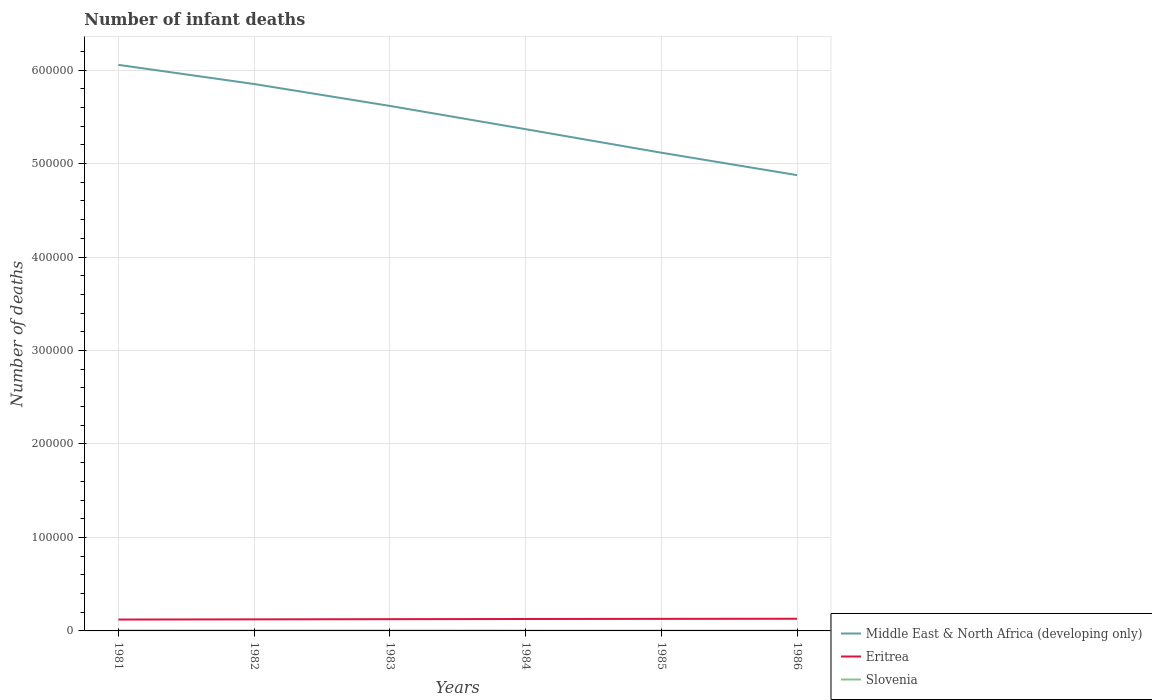How many different coloured lines are there?
Ensure brevity in your answer.  3. Across all years, what is the maximum number of infant deaths in Eritrea?
Provide a succinct answer. 1.22e+04. In which year was the number of infant deaths in Middle East & North Africa (developing only) maximum?
Your response must be concise. 1986. What is the total number of infant deaths in Eritrea in the graph?
Keep it short and to the point. -330. What is the difference between the highest and the second highest number of infant deaths in Eritrea?
Offer a terse response. 858. What is the difference between the highest and the lowest number of infant deaths in Slovenia?
Offer a very short reply. 3. Is the number of infant deaths in Middle East & North Africa (developing only) strictly greater than the number of infant deaths in Slovenia over the years?
Offer a terse response. No. How many years are there in the graph?
Provide a short and direct response. 6. What is the difference between two consecutive major ticks on the Y-axis?
Keep it short and to the point. 1.00e+05. Does the graph contain grids?
Provide a succinct answer. Yes. Where does the legend appear in the graph?
Your answer should be very brief. Bottom right. What is the title of the graph?
Keep it short and to the point. Number of infant deaths. What is the label or title of the Y-axis?
Keep it short and to the point. Number of deaths. What is the Number of deaths of Middle East & North Africa (developing only) in 1981?
Give a very brief answer. 6.06e+05. What is the Number of deaths in Eritrea in 1981?
Offer a very short reply. 1.22e+04. What is the Number of deaths in Slovenia in 1981?
Ensure brevity in your answer.  464. What is the Number of deaths in Middle East & North Africa (developing only) in 1982?
Provide a short and direct response. 5.85e+05. What is the Number of deaths of Eritrea in 1982?
Offer a terse response. 1.24e+04. What is the Number of deaths in Slovenia in 1982?
Make the answer very short. 424. What is the Number of deaths of Middle East & North Africa (developing only) in 1983?
Offer a very short reply. 5.62e+05. What is the Number of deaths in Eritrea in 1983?
Your answer should be compact. 1.26e+04. What is the Number of deaths of Slovenia in 1983?
Give a very brief answer. 387. What is the Number of deaths in Middle East & North Africa (developing only) in 1984?
Your answer should be very brief. 5.37e+05. What is the Number of deaths of Eritrea in 1984?
Provide a short and direct response. 1.28e+04. What is the Number of deaths of Slovenia in 1984?
Provide a short and direct response. 355. What is the Number of deaths of Middle East & North Africa (developing only) in 1985?
Keep it short and to the point. 5.12e+05. What is the Number of deaths in Eritrea in 1985?
Offer a terse response. 1.29e+04. What is the Number of deaths in Slovenia in 1985?
Offer a very short reply. 322. What is the Number of deaths of Middle East & North Africa (developing only) in 1986?
Give a very brief answer. 4.88e+05. What is the Number of deaths of Eritrea in 1986?
Your answer should be very brief. 1.30e+04. What is the Number of deaths of Slovenia in 1986?
Offer a very short reply. 295. Across all years, what is the maximum Number of deaths of Middle East & North Africa (developing only)?
Your answer should be compact. 6.06e+05. Across all years, what is the maximum Number of deaths of Eritrea?
Your response must be concise. 1.30e+04. Across all years, what is the maximum Number of deaths of Slovenia?
Your answer should be very brief. 464. Across all years, what is the minimum Number of deaths in Middle East & North Africa (developing only)?
Make the answer very short. 4.88e+05. Across all years, what is the minimum Number of deaths in Eritrea?
Provide a succinct answer. 1.22e+04. Across all years, what is the minimum Number of deaths of Slovenia?
Provide a succinct answer. 295. What is the total Number of deaths of Middle East & North Africa (developing only) in the graph?
Keep it short and to the point. 3.29e+06. What is the total Number of deaths of Eritrea in the graph?
Offer a very short reply. 7.58e+04. What is the total Number of deaths of Slovenia in the graph?
Your answer should be very brief. 2247. What is the difference between the Number of deaths of Middle East & North Africa (developing only) in 1981 and that in 1982?
Make the answer very short. 2.05e+04. What is the difference between the Number of deaths of Eritrea in 1981 and that in 1982?
Ensure brevity in your answer.  -206. What is the difference between the Number of deaths in Slovenia in 1981 and that in 1982?
Your answer should be compact. 40. What is the difference between the Number of deaths in Middle East & North Africa (developing only) in 1981 and that in 1983?
Offer a terse response. 4.39e+04. What is the difference between the Number of deaths in Eritrea in 1981 and that in 1983?
Give a very brief answer. -410. What is the difference between the Number of deaths of Slovenia in 1981 and that in 1983?
Your answer should be compact. 77. What is the difference between the Number of deaths of Middle East & North Africa (developing only) in 1981 and that in 1984?
Your answer should be very brief. 6.88e+04. What is the difference between the Number of deaths of Eritrea in 1981 and that in 1984?
Your answer should be compact. -592. What is the difference between the Number of deaths of Slovenia in 1981 and that in 1984?
Keep it short and to the point. 109. What is the difference between the Number of deaths of Middle East & North Africa (developing only) in 1981 and that in 1985?
Keep it short and to the point. 9.40e+04. What is the difference between the Number of deaths of Eritrea in 1981 and that in 1985?
Your answer should be very brief. -740. What is the difference between the Number of deaths in Slovenia in 1981 and that in 1985?
Your response must be concise. 142. What is the difference between the Number of deaths in Middle East & North Africa (developing only) in 1981 and that in 1986?
Make the answer very short. 1.18e+05. What is the difference between the Number of deaths in Eritrea in 1981 and that in 1986?
Offer a terse response. -858. What is the difference between the Number of deaths in Slovenia in 1981 and that in 1986?
Keep it short and to the point. 169. What is the difference between the Number of deaths in Middle East & North Africa (developing only) in 1982 and that in 1983?
Your response must be concise. 2.34e+04. What is the difference between the Number of deaths in Eritrea in 1982 and that in 1983?
Provide a succinct answer. -204. What is the difference between the Number of deaths of Middle East & North Africa (developing only) in 1982 and that in 1984?
Make the answer very short. 4.83e+04. What is the difference between the Number of deaths of Eritrea in 1982 and that in 1984?
Provide a succinct answer. -386. What is the difference between the Number of deaths of Slovenia in 1982 and that in 1984?
Give a very brief answer. 69. What is the difference between the Number of deaths of Middle East & North Africa (developing only) in 1982 and that in 1985?
Your response must be concise. 7.35e+04. What is the difference between the Number of deaths of Eritrea in 1982 and that in 1985?
Your answer should be compact. -534. What is the difference between the Number of deaths in Slovenia in 1982 and that in 1985?
Make the answer very short. 102. What is the difference between the Number of deaths in Middle East & North Africa (developing only) in 1982 and that in 1986?
Offer a terse response. 9.75e+04. What is the difference between the Number of deaths of Eritrea in 1982 and that in 1986?
Offer a terse response. -652. What is the difference between the Number of deaths of Slovenia in 1982 and that in 1986?
Your response must be concise. 129. What is the difference between the Number of deaths of Middle East & North Africa (developing only) in 1983 and that in 1984?
Offer a very short reply. 2.49e+04. What is the difference between the Number of deaths in Eritrea in 1983 and that in 1984?
Ensure brevity in your answer.  -182. What is the difference between the Number of deaths in Slovenia in 1983 and that in 1984?
Your response must be concise. 32. What is the difference between the Number of deaths in Middle East & North Africa (developing only) in 1983 and that in 1985?
Your response must be concise. 5.01e+04. What is the difference between the Number of deaths in Eritrea in 1983 and that in 1985?
Make the answer very short. -330. What is the difference between the Number of deaths in Middle East & North Africa (developing only) in 1983 and that in 1986?
Offer a very short reply. 7.41e+04. What is the difference between the Number of deaths of Eritrea in 1983 and that in 1986?
Provide a short and direct response. -448. What is the difference between the Number of deaths of Slovenia in 1983 and that in 1986?
Offer a terse response. 92. What is the difference between the Number of deaths in Middle East & North Africa (developing only) in 1984 and that in 1985?
Give a very brief answer. 2.52e+04. What is the difference between the Number of deaths of Eritrea in 1984 and that in 1985?
Your response must be concise. -148. What is the difference between the Number of deaths in Middle East & North Africa (developing only) in 1984 and that in 1986?
Your answer should be very brief. 4.92e+04. What is the difference between the Number of deaths of Eritrea in 1984 and that in 1986?
Offer a terse response. -266. What is the difference between the Number of deaths of Middle East & North Africa (developing only) in 1985 and that in 1986?
Provide a succinct answer. 2.40e+04. What is the difference between the Number of deaths of Eritrea in 1985 and that in 1986?
Your answer should be compact. -118. What is the difference between the Number of deaths in Slovenia in 1985 and that in 1986?
Give a very brief answer. 27. What is the difference between the Number of deaths of Middle East & North Africa (developing only) in 1981 and the Number of deaths of Eritrea in 1982?
Make the answer very short. 5.93e+05. What is the difference between the Number of deaths in Middle East & North Africa (developing only) in 1981 and the Number of deaths in Slovenia in 1982?
Give a very brief answer. 6.05e+05. What is the difference between the Number of deaths in Eritrea in 1981 and the Number of deaths in Slovenia in 1982?
Your response must be concise. 1.17e+04. What is the difference between the Number of deaths in Middle East & North Africa (developing only) in 1981 and the Number of deaths in Eritrea in 1983?
Give a very brief answer. 5.93e+05. What is the difference between the Number of deaths of Middle East & North Africa (developing only) in 1981 and the Number of deaths of Slovenia in 1983?
Give a very brief answer. 6.05e+05. What is the difference between the Number of deaths in Eritrea in 1981 and the Number of deaths in Slovenia in 1983?
Your response must be concise. 1.18e+04. What is the difference between the Number of deaths of Middle East & North Africa (developing only) in 1981 and the Number of deaths of Eritrea in 1984?
Provide a succinct answer. 5.93e+05. What is the difference between the Number of deaths in Middle East & North Africa (developing only) in 1981 and the Number of deaths in Slovenia in 1984?
Make the answer very short. 6.05e+05. What is the difference between the Number of deaths of Eritrea in 1981 and the Number of deaths of Slovenia in 1984?
Keep it short and to the point. 1.18e+04. What is the difference between the Number of deaths in Middle East & North Africa (developing only) in 1981 and the Number of deaths in Eritrea in 1985?
Make the answer very short. 5.93e+05. What is the difference between the Number of deaths of Middle East & North Africa (developing only) in 1981 and the Number of deaths of Slovenia in 1985?
Make the answer very short. 6.05e+05. What is the difference between the Number of deaths of Eritrea in 1981 and the Number of deaths of Slovenia in 1985?
Your answer should be compact. 1.18e+04. What is the difference between the Number of deaths in Middle East & North Africa (developing only) in 1981 and the Number of deaths in Eritrea in 1986?
Provide a short and direct response. 5.93e+05. What is the difference between the Number of deaths in Middle East & North Africa (developing only) in 1981 and the Number of deaths in Slovenia in 1986?
Your response must be concise. 6.05e+05. What is the difference between the Number of deaths of Eritrea in 1981 and the Number of deaths of Slovenia in 1986?
Offer a very short reply. 1.19e+04. What is the difference between the Number of deaths in Middle East & North Africa (developing only) in 1982 and the Number of deaths in Eritrea in 1983?
Provide a short and direct response. 5.73e+05. What is the difference between the Number of deaths of Middle East & North Africa (developing only) in 1982 and the Number of deaths of Slovenia in 1983?
Ensure brevity in your answer.  5.85e+05. What is the difference between the Number of deaths of Eritrea in 1982 and the Number of deaths of Slovenia in 1983?
Ensure brevity in your answer.  1.20e+04. What is the difference between the Number of deaths of Middle East & North Africa (developing only) in 1982 and the Number of deaths of Eritrea in 1984?
Your answer should be very brief. 5.72e+05. What is the difference between the Number of deaths in Middle East & North Africa (developing only) in 1982 and the Number of deaths in Slovenia in 1984?
Make the answer very short. 5.85e+05. What is the difference between the Number of deaths of Eritrea in 1982 and the Number of deaths of Slovenia in 1984?
Make the answer very short. 1.20e+04. What is the difference between the Number of deaths of Middle East & North Africa (developing only) in 1982 and the Number of deaths of Eritrea in 1985?
Offer a terse response. 5.72e+05. What is the difference between the Number of deaths in Middle East & North Africa (developing only) in 1982 and the Number of deaths in Slovenia in 1985?
Your response must be concise. 5.85e+05. What is the difference between the Number of deaths of Eritrea in 1982 and the Number of deaths of Slovenia in 1985?
Your answer should be very brief. 1.21e+04. What is the difference between the Number of deaths in Middle East & North Africa (developing only) in 1982 and the Number of deaths in Eritrea in 1986?
Offer a terse response. 5.72e+05. What is the difference between the Number of deaths of Middle East & North Africa (developing only) in 1982 and the Number of deaths of Slovenia in 1986?
Offer a terse response. 5.85e+05. What is the difference between the Number of deaths in Eritrea in 1982 and the Number of deaths in Slovenia in 1986?
Give a very brief answer. 1.21e+04. What is the difference between the Number of deaths in Middle East & North Africa (developing only) in 1983 and the Number of deaths in Eritrea in 1984?
Provide a short and direct response. 5.49e+05. What is the difference between the Number of deaths of Middle East & North Africa (developing only) in 1983 and the Number of deaths of Slovenia in 1984?
Keep it short and to the point. 5.61e+05. What is the difference between the Number of deaths in Eritrea in 1983 and the Number of deaths in Slovenia in 1984?
Offer a terse response. 1.22e+04. What is the difference between the Number of deaths in Middle East & North Africa (developing only) in 1983 and the Number of deaths in Eritrea in 1985?
Ensure brevity in your answer.  5.49e+05. What is the difference between the Number of deaths in Middle East & North Africa (developing only) in 1983 and the Number of deaths in Slovenia in 1985?
Your answer should be compact. 5.61e+05. What is the difference between the Number of deaths of Eritrea in 1983 and the Number of deaths of Slovenia in 1985?
Your answer should be compact. 1.23e+04. What is the difference between the Number of deaths in Middle East & North Africa (developing only) in 1983 and the Number of deaths in Eritrea in 1986?
Provide a short and direct response. 5.49e+05. What is the difference between the Number of deaths in Middle East & North Africa (developing only) in 1983 and the Number of deaths in Slovenia in 1986?
Offer a very short reply. 5.61e+05. What is the difference between the Number of deaths in Eritrea in 1983 and the Number of deaths in Slovenia in 1986?
Offer a terse response. 1.23e+04. What is the difference between the Number of deaths in Middle East & North Africa (developing only) in 1984 and the Number of deaths in Eritrea in 1985?
Provide a short and direct response. 5.24e+05. What is the difference between the Number of deaths in Middle East & North Africa (developing only) in 1984 and the Number of deaths in Slovenia in 1985?
Provide a succinct answer. 5.37e+05. What is the difference between the Number of deaths in Eritrea in 1984 and the Number of deaths in Slovenia in 1985?
Give a very brief answer. 1.24e+04. What is the difference between the Number of deaths in Middle East & North Africa (developing only) in 1984 and the Number of deaths in Eritrea in 1986?
Offer a very short reply. 5.24e+05. What is the difference between the Number of deaths in Middle East & North Africa (developing only) in 1984 and the Number of deaths in Slovenia in 1986?
Your answer should be very brief. 5.37e+05. What is the difference between the Number of deaths in Eritrea in 1984 and the Number of deaths in Slovenia in 1986?
Offer a very short reply. 1.25e+04. What is the difference between the Number of deaths of Middle East & North Africa (developing only) in 1985 and the Number of deaths of Eritrea in 1986?
Offer a terse response. 4.99e+05. What is the difference between the Number of deaths of Middle East & North Africa (developing only) in 1985 and the Number of deaths of Slovenia in 1986?
Make the answer very short. 5.11e+05. What is the difference between the Number of deaths of Eritrea in 1985 and the Number of deaths of Slovenia in 1986?
Your answer should be very brief. 1.26e+04. What is the average Number of deaths in Middle East & North Africa (developing only) per year?
Give a very brief answer. 5.48e+05. What is the average Number of deaths of Eritrea per year?
Give a very brief answer. 1.26e+04. What is the average Number of deaths in Slovenia per year?
Give a very brief answer. 374.5. In the year 1981, what is the difference between the Number of deaths in Middle East & North Africa (developing only) and Number of deaths in Eritrea?
Offer a very short reply. 5.93e+05. In the year 1981, what is the difference between the Number of deaths of Middle East & North Africa (developing only) and Number of deaths of Slovenia?
Keep it short and to the point. 6.05e+05. In the year 1981, what is the difference between the Number of deaths in Eritrea and Number of deaths in Slovenia?
Provide a succinct answer. 1.17e+04. In the year 1982, what is the difference between the Number of deaths in Middle East & North Africa (developing only) and Number of deaths in Eritrea?
Your response must be concise. 5.73e+05. In the year 1982, what is the difference between the Number of deaths of Middle East & North Africa (developing only) and Number of deaths of Slovenia?
Offer a very short reply. 5.85e+05. In the year 1982, what is the difference between the Number of deaths of Eritrea and Number of deaths of Slovenia?
Provide a succinct answer. 1.20e+04. In the year 1983, what is the difference between the Number of deaths of Middle East & North Africa (developing only) and Number of deaths of Eritrea?
Provide a succinct answer. 5.49e+05. In the year 1983, what is the difference between the Number of deaths of Middle East & North Africa (developing only) and Number of deaths of Slovenia?
Your answer should be compact. 5.61e+05. In the year 1983, what is the difference between the Number of deaths of Eritrea and Number of deaths of Slovenia?
Offer a very short reply. 1.22e+04. In the year 1984, what is the difference between the Number of deaths of Middle East & North Africa (developing only) and Number of deaths of Eritrea?
Offer a terse response. 5.24e+05. In the year 1984, what is the difference between the Number of deaths in Middle East & North Africa (developing only) and Number of deaths in Slovenia?
Provide a short and direct response. 5.36e+05. In the year 1984, what is the difference between the Number of deaths in Eritrea and Number of deaths in Slovenia?
Provide a succinct answer. 1.24e+04. In the year 1985, what is the difference between the Number of deaths of Middle East & North Africa (developing only) and Number of deaths of Eritrea?
Offer a very short reply. 4.99e+05. In the year 1985, what is the difference between the Number of deaths of Middle East & North Africa (developing only) and Number of deaths of Slovenia?
Keep it short and to the point. 5.11e+05. In the year 1985, what is the difference between the Number of deaths in Eritrea and Number of deaths in Slovenia?
Provide a short and direct response. 1.26e+04. In the year 1986, what is the difference between the Number of deaths of Middle East & North Africa (developing only) and Number of deaths of Eritrea?
Make the answer very short. 4.75e+05. In the year 1986, what is the difference between the Number of deaths of Middle East & North Africa (developing only) and Number of deaths of Slovenia?
Offer a very short reply. 4.87e+05. In the year 1986, what is the difference between the Number of deaths of Eritrea and Number of deaths of Slovenia?
Ensure brevity in your answer.  1.27e+04. What is the ratio of the Number of deaths of Middle East & North Africa (developing only) in 1981 to that in 1982?
Ensure brevity in your answer.  1.03. What is the ratio of the Number of deaths of Eritrea in 1981 to that in 1982?
Your answer should be very brief. 0.98. What is the ratio of the Number of deaths in Slovenia in 1981 to that in 1982?
Your answer should be very brief. 1.09. What is the ratio of the Number of deaths of Middle East & North Africa (developing only) in 1981 to that in 1983?
Offer a very short reply. 1.08. What is the ratio of the Number of deaths of Eritrea in 1981 to that in 1983?
Keep it short and to the point. 0.97. What is the ratio of the Number of deaths in Slovenia in 1981 to that in 1983?
Keep it short and to the point. 1.2. What is the ratio of the Number of deaths in Middle East & North Africa (developing only) in 1981 to that in 1984?
Provide a short and direct response. 1.13. What is the ratio of the Number of deaths of Eritrea in 1981 to that in 1984?
Provide a short and direct response. 0.95. What is the ratio of the Number of deaths in Slovenia in 1981 to that in 1984?
Give a very brief answer. 1.31. What is the ratio of the Number of deaths of Middle East & North Africa (developing only) in 1981 to that in 1985?
Provide a succinct answer. 1.18. What is the ratio of the Number of deaths in Eritrea in 1981 to that in 1985?
Provide a succinct answer. 0.94. What is the ratio of the Number of deaths of Slovenia in 1981 to that in 1985?
Keep it short and to the point. 1.44. What is the ratio of the Number of deaths of Middle East & North Africa (developing only) in 1981 to that in 1986?
Make the answer very short. 1.24. What is the ratio of the Number of deaths in Eritrea in 1981 to that in 1986?
Keep it short and to the point. 0.93. What is the ratio of the Number of deaths of Slovenia in 1981 to that in 1986?
Offer a very short reply. 1.57. What is the ratio of the Number of deaths in Middle East & North Africa (developing only) in 1982 to that in 1983?
Keep it short and to the point. 1.04. What is the ratio of the Number of deaths in Eritrea in 1982 to that in 1983?
Give a very brief answer. 0.98. What is the ratio of the Number of deaths in Slovenia in 1982 to that in 1983?
Make the answer very short. 1.1. What is the ratio of the Number of deaths of Middle East & North Africa (developing only) in 1982 to that in 1984?
Keep it short and to the point. 1.09. What is the ratio of the Number of deaths in Eritrea in 1982 to that in 1984?
Your answer should be compact. 0.97. What is the ratio of the Number of deaths in Slovenia in 1982 to that in 1984?
Keep it short and to the point. 1.19. What is the ratio of the Number of deaths of Middle East & North Africa (developing only) in 1982 to that in 1985?
Your answer should be compact. 1.14. What is the ratio of the Number of deaths in Eritrea in 1982 to that in 1985?
Offer a very short reply. 0.96. What is the ratio of the Number of deaths in Slovenia in 1982 to that in 1985?
Give a very brief answer. 1.32. What is the ratio of the Number of deaths of Middle East & North Africa (developing only) in 1982 to that in 1986?
Your response must be concise. 1.2. What is the ratio of the Number of deaths of Eritrea in 1982 to that in 1986?
Keep it short and to the point. 0.95. What is the ratio of the Number of deaths in Slovenia in 1982 to that in 1986?
Ensure brevity in your answer.  1.44. What is the ratio of the Number of deaths of Middle East & North Africa (developing only) in 1983 to that in 1984?
Your response must be concise. 1.05. What is the ratio of the Number of deaths of Eritrea in 1983 to that in 1984?
Give a very brief answer. 0.99. What is the ratio of the Number of deaths in Slovenia in 1983 to that in 1984?
Provide a short and direct response. 1.09. What is the ratio of the Number of deaths in Middle East & North Africa (developing only) in 1983 to that in 1985?
Give a very brief answer. 1.1. What is the ratio of the Number of deaths in Eritrea in 1983 to that in 1985?
Provide a short and direct response. 0.97. What is the ratio of the Number of deaths of Slovenia in 1983 to that in 1985?
Offer a very short reply. 1.2. What is the ratio of the Number of deaths of Middle East & North Africa (developing only) in 1983 to that in 1986?
Make the answer very short. 1.15. What is the ratio of the Number of deaths in Eritrea in 1983 to that in 1986?
Your response must be concise. 0.97. What is the ratio of the Number of deaths in Slovenia in 1983 to that in 1986?
Provide a short and direct response. 1.31. What is the ratio of the Number of deaths of Middle East & North Africa (developing only) in 1984 to that in 1985?
Provide a succinct answer. 1.05. What is the ratio of the Number of deaths of Eritrea in 1984 to that in 1985?
Offer a very short reply. 0.99. What is the ratio of the Number of deaths of Slovenia in 1984 to that in 1985?
Offer a terse response. 1.1. What is the ratio of the Number of deaths of Middle East & North Africa (developing only) in 1984 to that in 1986?
Provide a succinct answer. 1.1. What is the ratio of the Number of deaths of Eritrea in 1984 to that in 1986?
Offer a very short reply. 0.98. What is the ratio of the Number of deaths in Slovenia in 1984 to that in 1986?
Keep it short and to the point. 1.2. What is the ratio of the Number of deaths of Middle East & North Africa (developing only) in 1985 to that in 1986?
Ensure brevity in your answer.  1.05. What is the ratio of the Number of deaths in Eritrea in 1985 to that in 1986?
Your answer should be very brief. 0.99. What is the ratio of the Number of deaths of Slovenia in 1985 to that in 1986?
Make the answer very short. 1.09. What is the difference between the highest and the second highest Number of deaths of Middle East & North Africa (developing only)?
Provide a short and direct response. 2.05e+04. What is the difference between the highest and the second highest Number of deaths in Eritrea?
Make the answer very short. 118. What is the difference between the highest and the lowest Number of deaths of Middle East & North Africa (developing only)?
Provide a succinct answer. 1.18e+05. What is the difference between the highest and the lowest Number of deaths of Eritrea?
Your answer should be compact. 858. What is the difference between the highest and the lowest Number of deaths in Slovenia?
Your answer should be very brief. 169. 